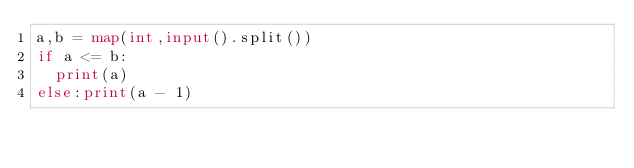Convert code to text. <code><loc_0><loc_0><loc_500><loc_500><_Python_>a,b = map(int,input().split())
if a <= b:
  print(a)
else:print(a - 1)</code> 